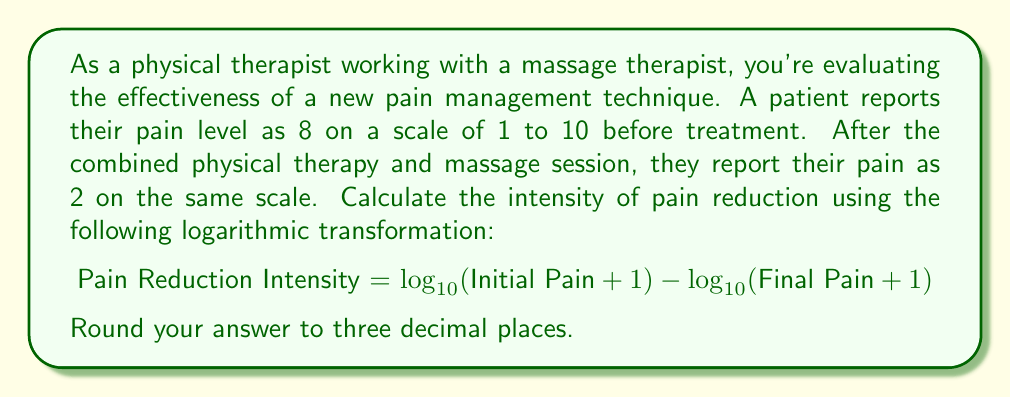Show me your answer to this math problem. To solve this problem, we'll follow these steps:

1. Identify the initial and final pain levels:
   Initial Pain = 8
   Final Pain = 2

2. Apply the logarithmic transformation formula:
   Pain Reduction Intensity = $\log_{10}(\text{Initial Pain} + 1) - \log_{10}(\text{Final Pain} + 1)$

3. Substitute the values into the formula:
   Pain Reduction Intensity = $\log_{10}(8 + 1) - \log_{10}(2 + 1)$
                            = $\log_{10}(9) - \log_{10}(3)$

4. Calculate the logarithms:
   $\log_{10}(9) \approx 0.9542425094$
   $\log_{10}(3) \approx 0.4771212547$

5. Subtract the logarithms:
   Pain Reduction Intensity = $0.9542425094 - 0.4771212547$
                            = $0.4771212547$

6. Round the result to three decimal places:
   Pain Reduction Intensity ≈ 0.477

This logarithmic transformation helps to quantify pain reduction on a more meaningful scale, as it accounts for the non-linear nature of perceived pain intensity.
Answer: The intensity of pain reduction using the logarithmic transformation is approximately 0.477. 